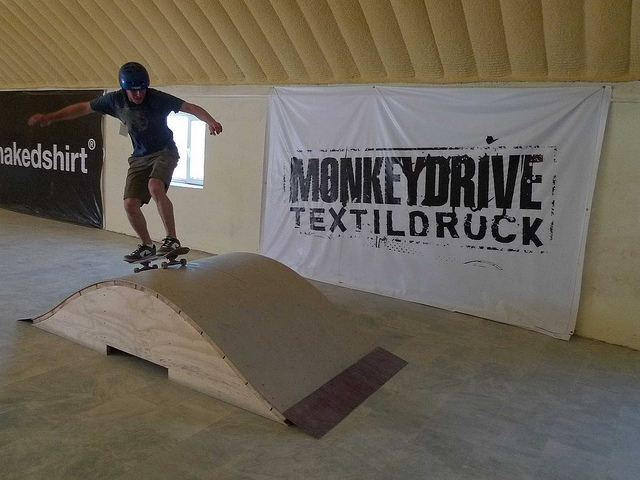Extract all visible text content from this image. MONKEYDRIVE TEXTILDRUCK Shakedshirt 